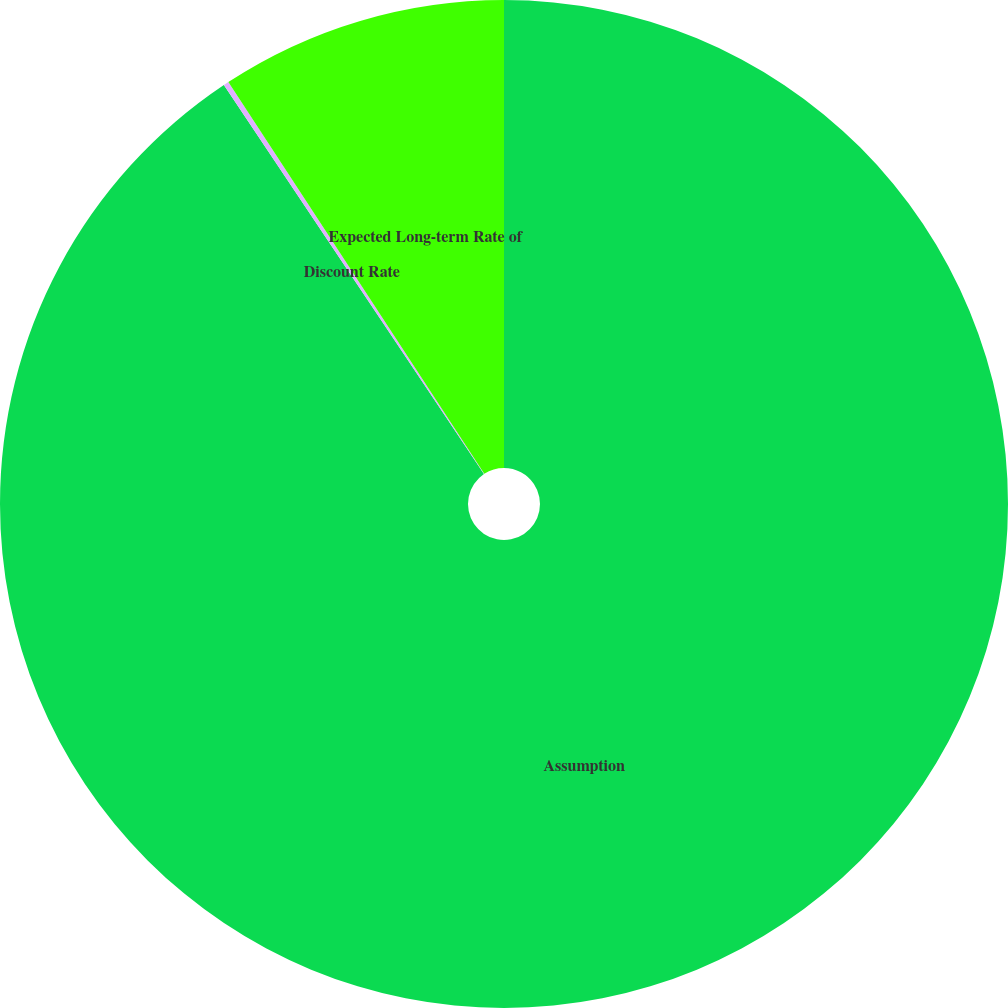Convert chart to OTSL. <chart><loc_0><loc_0><loc_500><loc_500><pie_chart><fcel>Assumption<fcel>Discount Rate<fcel>Expected Long-term Rate of<nl><fcel>90.62%<fcel>0.17%<fcel>9.21%<nl></chart> 